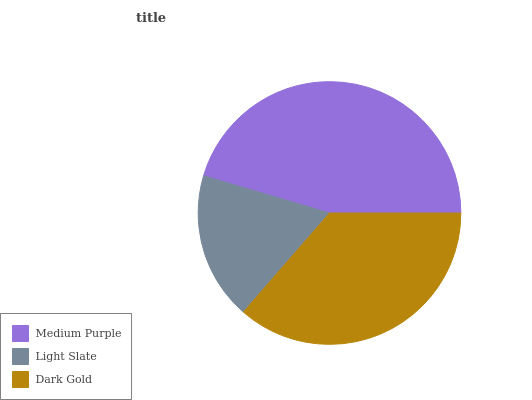Is Light Slate the minimum?
Answer yes or no. Yes. Is Medium Purple the maximum?
Answer yes or no. Yes. Is Dark Gold the minimum?
Answer yes or no. No. Is Dark Gold the maximum?
Answer yes or no. No. Is Dark Gold greater than Light Slate?
Answer yes or no. Yes. Is Light Slate less than Dark Gold?
Answer yes or no. Yes. Is Light Slate greater than Dark Gold?
Answer yes or no. No. Is Dark Gold less than Light Slate?
Answer yes or no. No. Is Dark Gold the high median?
Answer yes or no. Yes. Is Dark Gold the low median?
Answer yes or no. Yes. Is Medium Purple the high median?
Answer yes or no. No. Is Light Slate the low median?
Answer yes or no. No. 